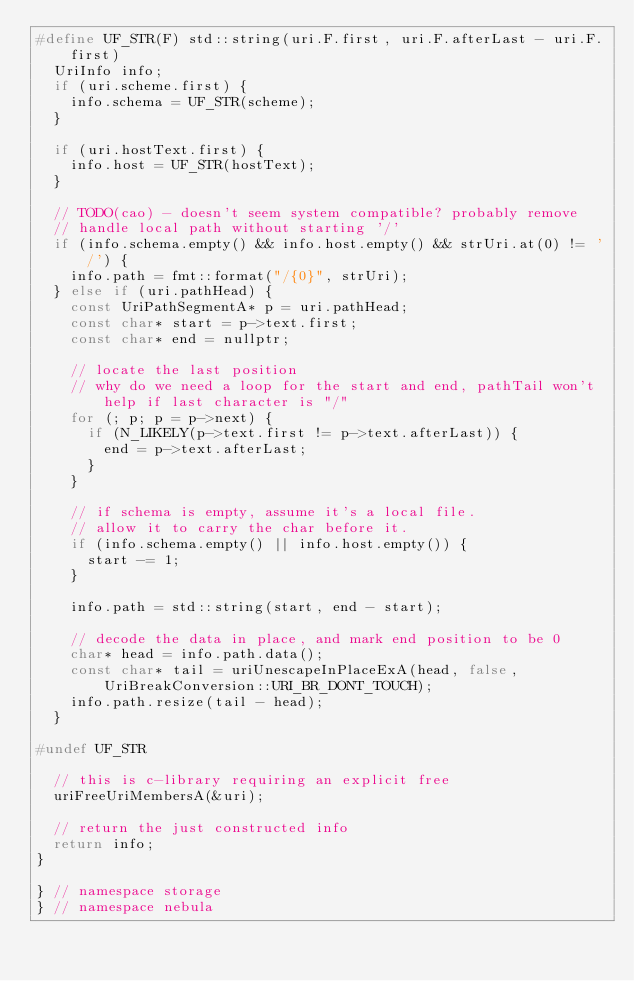<code> <loc_0><loc_0><loc_500><loc_500><_C++_>#define UF_STR(F) std::string(uri.F.first, uri.F.afterLast - uri.F.first)
  UriInfo info;
  if (uri.scheme.first) {
    info.schema = UF_STR(scheme);
  }

  if (uri.hostText.first) {
    info.host = UF_STR(hostText);
  }

  // TODO(cao) - doesn't seem system compatible? probably remove
  // handle local path without starting '/'
  if (info.schema.empty() && info.host.empty() && strUri.at(0) != '/') {
    info.path = fmt::format("/{0}", strUri);
  } else if (uri.pathHead) {
    const UriPathSegmentA* p = uri.pathHead;
    const char* start = p->text.first;
    const char* end = nullptr;

    // locate the last position
    // why do we need a loop for the start and end, pathTail won't help if last character is "/"
    for (; p; p = p->next) {
      if (N_LIKELY(p->text.first != p->text.afterLast)) {
        end = p->text.afterLast;
      }
    }

    // if schema is empty, assume it's a local file.
    // allow it to carry the char before it.
    if (info.schema.empty() || info.host.empty()) {
      start -= 1;
    }

    info.path = std::string(start, end - start);

    // decode the data in place, and mark end position to be 0
    char* head = info.path.data();
    const char* tail = uriUnescapeInPlaceExA(head, false, UriBreakConversion::URI_BR_DONT_TOUCH);
    info.path.resize(tail - head);
  }

#undef UF_STR

  // this is c-library requiring an explicit free
  uriFreeUriMembersA(&uri);

  // return the just constructed info
  return info;
}

} // namespace storage
} // namespace nebula</code> 